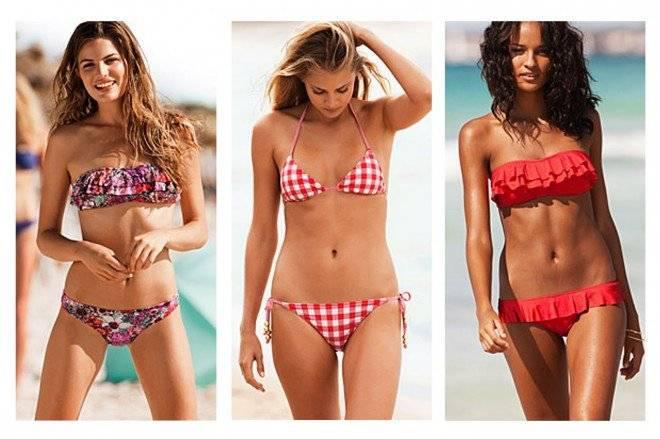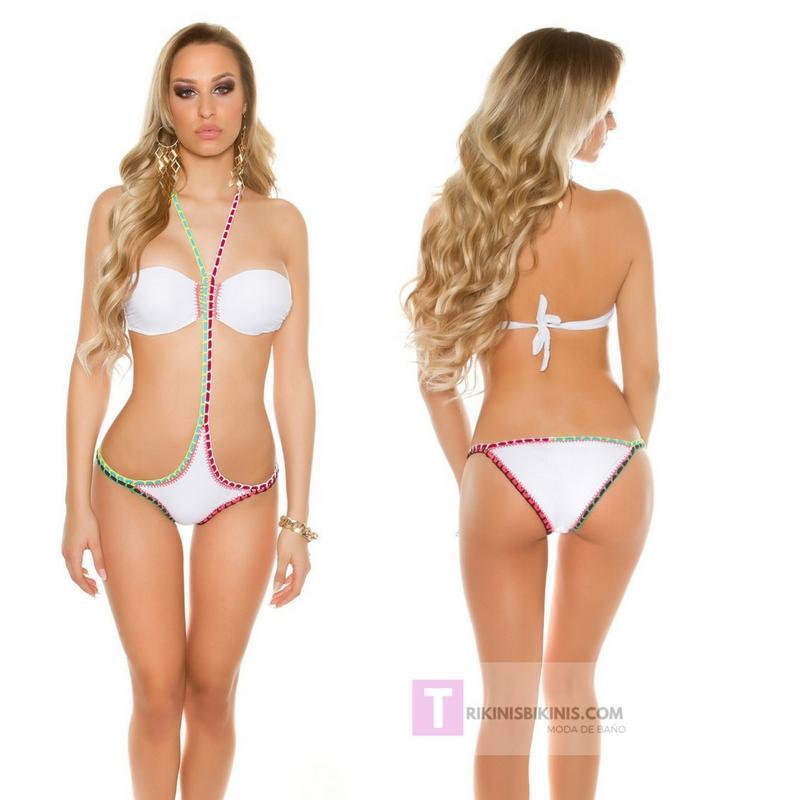The first image is the image on the left, the second image is the image on the right. Considering the images on both sides, is "One image shows a girl in a bikini with straps and solid color, standing with one hand on her upper hip." valid? Answer yes or no. No. The first image is the image on the left, the second image is the image on the right. Considering the images on both sides, is "A woman is touching her hair." valid? Answer yes or no. Yes. 